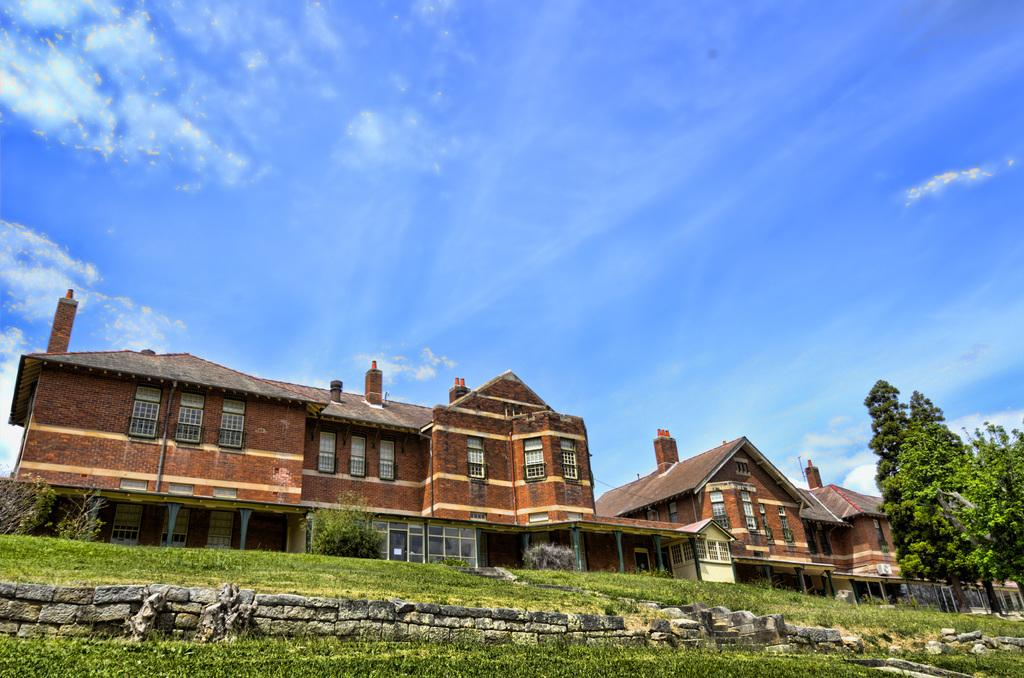What type of vegetation is at the bottom of the image? There is grass at the bottom of the image. What structures can be seen in the foreground of the image? There are houses and trees in the foreground of the image. What is visible at the top of the image? The sky is visible at the top of the image. Where is the cemetery located in the image? There is no cemetery present in the image. What type of ocean can be seen in the image? There is no ocean present in the image. 